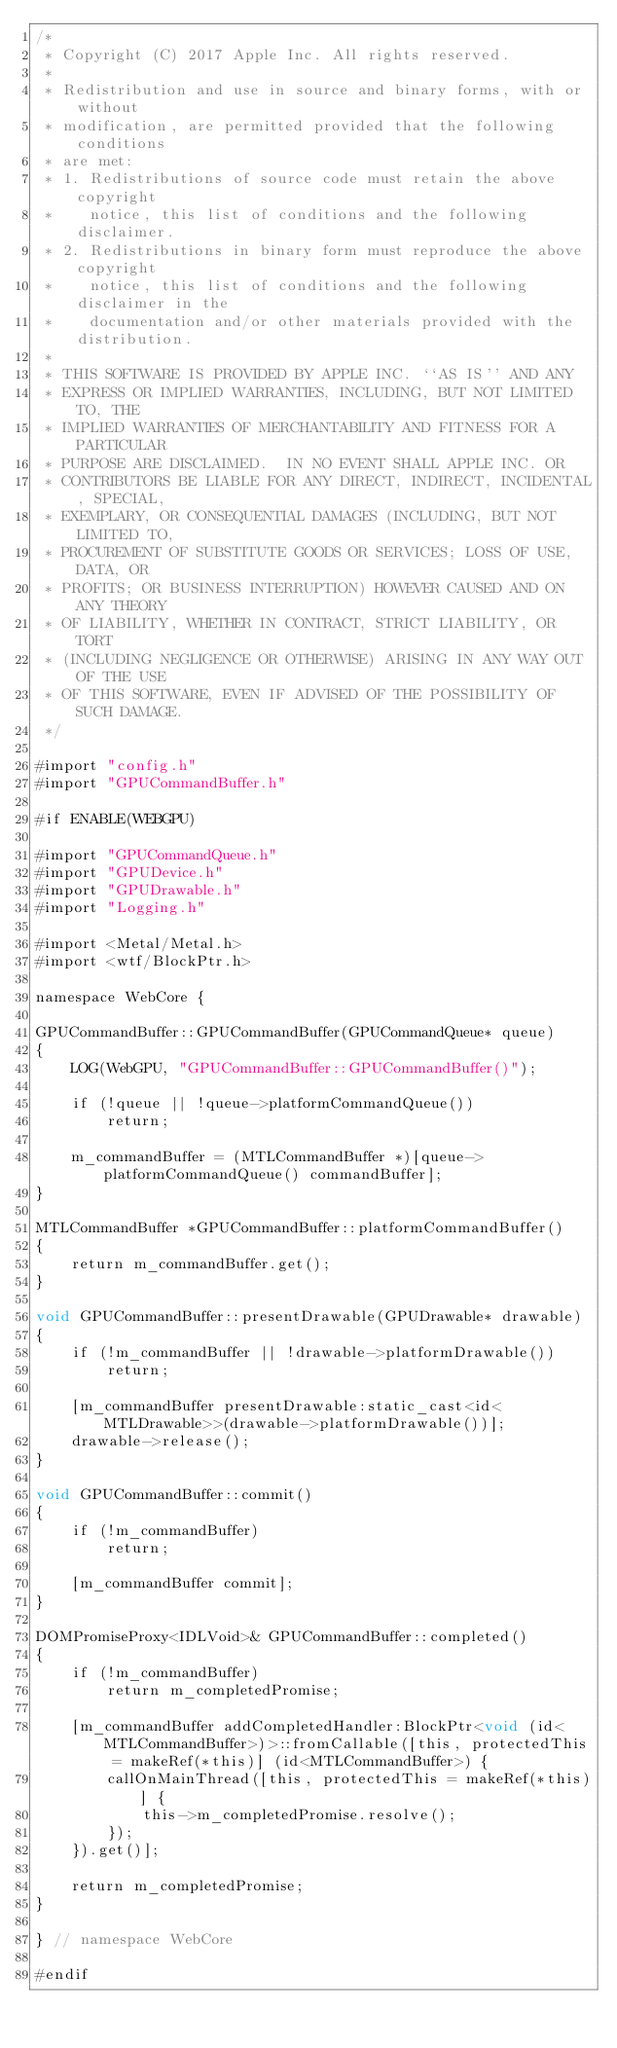<code> <loc_0><loc_0><loc_500><loc_500><_ObjectiveC_>/*
 * Copyright (C) 2017 Apple Inc. All rights reserved.
 *
 * Redistribution and use in source and binary forms, with or without
 * modification, are permitted provided that the following conditions
 * are met:
 * 1. Redistributions of source code must retain the above copyright
 *    notice, this list of conditions and the following disclaimer.
 * 2. Redistributions in binary form must reproduce the above copyright
 *    notice, this list of conditions and the following disclaimer in the
 *    documentation and/or other materials provided with the distribution.
 *
 * THIS SOFTWARE IS PROVIDED BY APPLE INC. ``AS IS'' AND ANY
 * EXPRESS OR IMPLIED WARRANTIES, INCLUDING, BUT NOT LIMITED TO, THE
 * IMPLIED WARRANTIES OF MERCHANTABILITY AND FITNESS FOR A PARTICULAR
 * PURPOSE ARE DISCLAIMED.  IN NO EVENT SHALL APPLE INC. OR
 * CONTRIBUTORS BE LIABLE FOR ANY DIRECT, INDIRECT, INCIDENTAL, SPECIAL,
 * EXEMPLARY, OR CONSEQUENTIAL DAMAGES (INCLUDING, BUT NOT LIMITED TO,
 * PROCUREMENT OF SUBSTITUTE GOODS OR SERVICES; LOSS OF USE, DATA, OR
 * PROFITS; OR BUSINESS INTERRUPTION) HOWEVER CAUSED AND ON ANY THEORY
 * OF LIABILITY, WHETHER IN CONTRACT, STRICT LIABILITY, OR TORT
 * (INCLUDING NEGLIGENCE OR OTHERWISE) ARISING IN ANY WAY OUT OF THE USE
 * OF THIS SOFTWARE, EVEN IF ADVISED OF THE POSSIBILITY OF SUCH DAMAGE.
 */

#import "config.h"
#import "GPUCommandBuffer.h"

#if ENABLE(WEBGPU)

#import "GPUCommandQueue.h"
#import "GPUDevice.h"
#import "GPUDrawable.h"
#import "Logging.h"

#import <Metal/Metal.h>
#import <wtf/BlockPtr.h>

namespace WebCore {

GPUCommandBuffer::GPUCommandBuffer(GPUCommandQueue* queue)
{
    LOG(WebGPU, "GPUCommandBuffer::GPUCommandBuffer()");

    if (!queue || !queue->platformCommandQueue())
        return;

    m_commandBuffer = (MTLCommandBuffer *)[queue->platformCommandQueue() commandBuffer];
}

MTLCommandBuffer *GPUCommandBuffer::platformCommandBuffer()
{
    return m_commandBuffer.get();
}

void GPUCommandBuffer::presentDrawable(GPUDrawable* drawable)
{
    if (!m_commandBuffer || !drawable->platformDrawable())
        return;

    [m_commandBuffer presentDrawable:static_cast<id<MTLDrawable>>(drawable->platformDrawable())];
    drawable->release();
}

void GPUCommandBuffer::commit()
{
    if (!m_commandBuffer)
        return;

    [m_commandBuffer commit];
}

DOMPromiseProxy<IDLVoid>& GPUCommandBuffer::completed()
{
    if (!m_commandBuffer)
        return m_completedPromise;

    [m_commandBuffer addCompletedHandler:BlockPtr<void (id<MTLCommandBuffer>)>::fromCallable([this, protectedThis = makeRef(*this)] (id<MTLCommandBuffer>) {
        callOnMainThread([this, protectedThis = makeRef(*this)] {
            this->m_completedPromise.resolve();
        });
    }).get()];
    
    return m_completedPromise;
}

} // namespace WebCore

#endif
</code> 